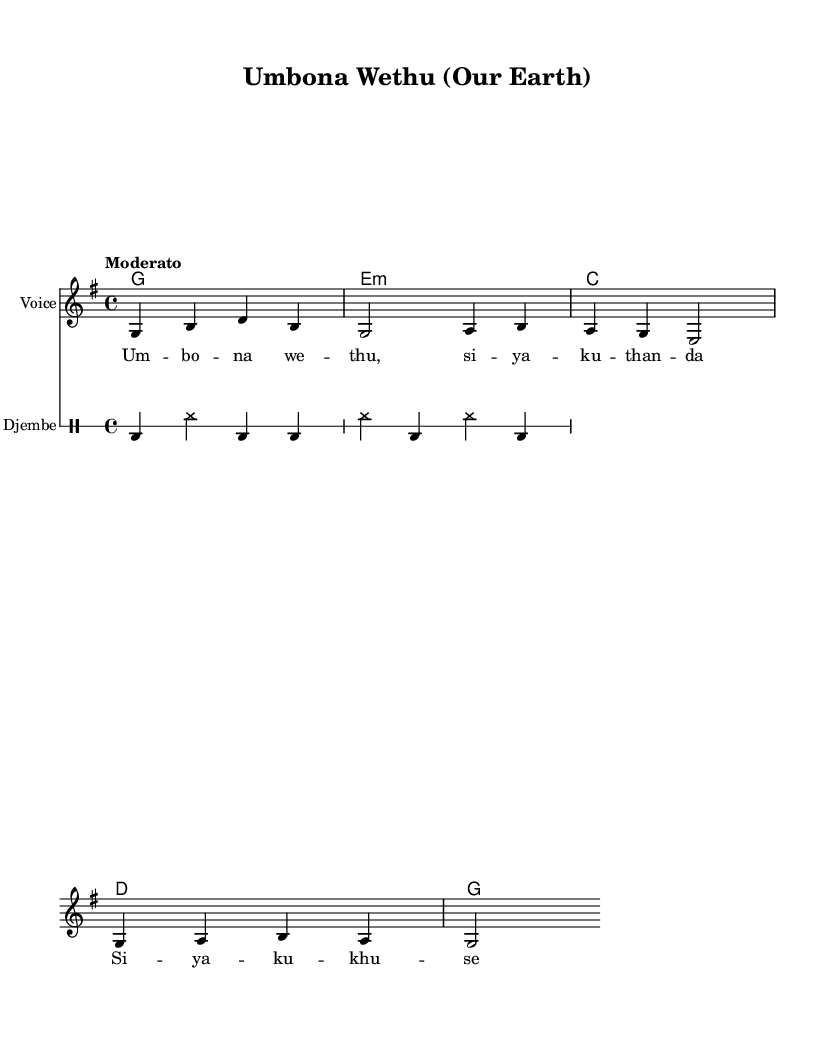What is the key signature of this music? The key signature is G major, which has one sharp. The sharp is F#, indicating that the music is composed in the scale of G major.
Answer: G major What is the time signature of the piece? The time signature is 4/4, which means there are four beats in each measure and a quarter note gets one beat. This is indicated at the beginning of the sheet music.
Answer: 4/4 What is the tempo marking for this piece? The tempo marking is "Moderato". This means the piece should be played at a moderately slow pace, reflecting a relaxed but steady rhythm.
Answer: Moderato How many measures are in the melody? The melody consists of 5 measures, which can be counted by observing the vertical lines that separate the measures in the sheet music.
Answer: 5 Which instrument is featured as the Djembe? The Djembe is represented in a separate staff with a unique notation. This percussion instrument typically plays a rhythmic pattern and is indicated clearly in the "DrumStaff" section of the score.
Answer: Djembe What chord follows the G major chord in the harmony? The G major chord is followed by an E minor chord as indicated in the chord progression. This can be identified by looking at the chord symbols listed above the melody.
Answer: E minor 